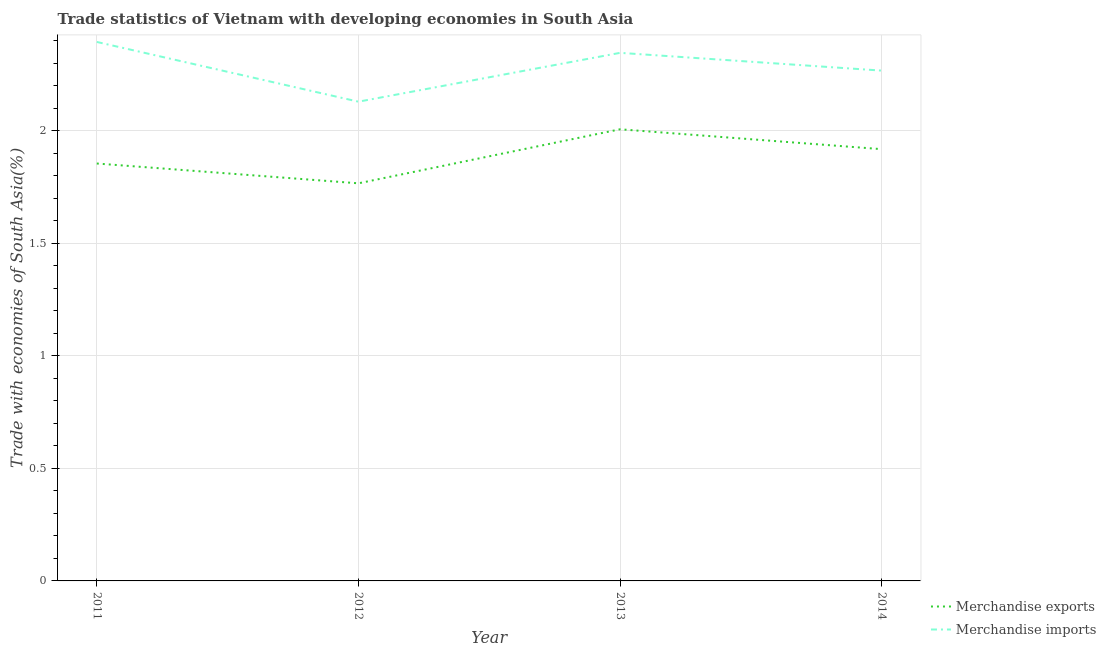How many different coloured lines are there?
Your answer should be compact. 2. What is the merchandise exports in 2014?
Keep it short and to the point. 1.92. Across all years, what is the maximum merchandise imports?
Keep it short and to the point. 2.39. Across all years, what is the minimum merchandise imports?
Ensure brevity in your answer.  2.13. What is the total merchandise imports in the graph?
Make the answer very short. 9.14. What is the difference between the merchandise imports in 2011 and that in 2013?
Provide a short and direct response. 0.05. What is the difference between the merchandise imports in 2012 and the merchandise exports in 2014?
Keep it short and to the point. 0.21. What is the average merchandise exports per year?
Ensure brevity in your answer.  1.89. In the year 2013, what is the difference between the merchandise imports and merchandise exports?
Your answer should be very brief. 0.34. What is the ratio of the merchandise exports in 2013 to that in 2014?
Your answer should be very brief. 1.05. Is the merchandise exports in 2011 less than that in 2012?
Offer a very short reply. No. What is the difference between the highest and the second highest merchandise imports?
Offer a very short reply. 0.05. What is the difference between the highest and the lowest merchandise imports?
Keep it short and to the point. 0.27. Is the merchandise exports strictly greater than the merchandise imports over the years?
Your answer should be compact. No. How many lines are there?
Give a very brief answer. 2. What is the difference between two consecutive major ticks on the Y-axis?
Provide a succinct answer. 0.5. Does the graph contain any zero values?
Make the answer very short. No. How many legend labels are there?
Provide a short and direct response. 2. How are the legend labels stacked?
Your answer should be compact. Vertical. What is the title of the graph?
Ensure brevity in your answer.  Trade statistics of Vietnam with developing economies in South Asia. What is the label or title of the X-axis?
Provide a succinct answer. Year. What is the label or title of the Y-axis?
Ensure brevity in your answer.  Trade with economies of South Asia(%). What is the Trade with economies of South Asia(%) in Merchandise exports in 2011?
Give a very brief answer. 1.85. What is the Trade with economies of South Asia(%) of Merchandise imports in 2011?
Your response must be concise. 2.39. What is the Trade with economies of South Asia(%) in Merchandise exports in 2012?
Provide a short and direct response. 1.77. What is the Trade with economies of South Asia(%) in Merchandise imports in 2012?
Keep it short and to the point. 2.13. What is the Trade with economies of South Asia(%) of Merchandise exports in 2013?
Offer a very short reply. 2.01. What is the Trade with economies of South Asia(%) of Merchandise imports in 2013?
Your response must be concise. 2.35. What is the Trade with economies of South Asia(%) of Merchandise exports in 2014?
Offer a very short reply. 1.92. What is the Trade with economies of South Asia(%) of Merchandise imports in 2014?
Give a very brief answer. 2.27. Across all years, what is the maximum Trade with economies of South Asia(%) of Merchandise exports?
Keep it short and to the point. 2.01. Across all years, what is the maximum Trade with economies of South Asia(%) in Merchandise imports?
Offer a terse response. 2.39. Across all years, what is the minimum Trade with economies of South Asia(%) of Merchandise exports?
Provide a succinct answer. 1.77. Across all years, what is the minimum Trade with economies of South Asia(%) in Merchandise imports?
Your response must be concise. 2.13. What is the total Trade with economies of South Asia(%) in Merchandise exports in the graph?
Your answer should be compact. 7.55. What is the total Trade with economies of South Asia(%) in Merchandise imports in the graph?
Your answer should be very brief. 9.14. What is the difference between the Trade with economies of South Asia(%) in Merchandise exports in 2011 and that in 2012?
Ensure brevity in your answer.  0.09. What is the difference between the Trade with economies of South Asia(%) in Merchandise imports in 2011 and that in 2012?
Offer a very short reply. 0.27. What is the difference between the Trade with economies of South Asia(%) of Merchandise exports in 2011 and that in 2013?
Keep it short and to the point. -0.15. What is the difference between the Trade with economies of South Asia(%) of Merchandise imports in 2011 and that in 2013?
Your answer should be compact. 0.05. What is the difference between the Trade with economies of South Asia(%) of Merchandise exports in 2011 and that in 2014?
Make the answer very short. -0.06. What is the difference between the Trade with economies of South Asia(%) in Merchandise imports in 2011 and that in 2014?
Your answer should be compact. 0.13. What is the difference between the Trade with economies of South Asia(%) in Merchandise exports in 2012 and that in 2013?
Provide a short and direct response. -0.24. What is the difference between the Trade with economies of South Asia(%) of Merchandise imports in 2012 and that in 2013?
Offer a very short reply. -0.22. What is the difference between the Trade with economies of South Asia(%) of Merchandise exports in 2012 and that in 2014?
Offer a very short reply. -0.15. What is the difference between the Trade with economies of South Asia(%) of Merchandise imports in 2012 and that in 2014?
Provide a succinct answer. -0.14. What is the difference between the Trade with economies of South Asia(%) of Merchandise exports in 2013 and that in 2014?
Keep it short and to the point. 0.09. What is the difference between the Trade with economies of South Asia(%) of Merchandise imports in 2013 and that in 2014?
Give a very brief answer. 0.08. What is the difference between the Trade with economies of South Asia(%) of Merchandise exports in 2011 and the Trade with economies of South Asia(%) of Merchandise imports in 2012?
Your answer should be compact. -0.27. What is the difference between the Trade with economies of South Asia(%) in Merchandise exports in 2011 and the Trade with economies of South Asia(%) in Merchandise imports in 2013?
Offer a terse response. -0.49. What is the difference between the Trade with economies of South Asia(%) in Merchandise exports in 2011 and the Trade with economies of South Asia(%) in Merchandise imports in 2014?
Ensure brevity in your answer.  -0.41. What is the difference between the Trade with economies of South Asia(%) in Merchandise exports in 2012 and the Trade with economies of South Asia(%) in Merchandise imports in 2013?
Give a very brief answer. -0.58. What is the difference between the Trade with economies of South Asia(%) in Merchandise exports in 2012 and the Trade with economies of South Asia(%) in Merchandise imports in 2014?
Provide a succinct answer. -0.5. What is the difference between the Trade with economies of South Asia(%) of Merchandise exports in 2013 and the Trade with economies of South Asia(%) of Merchandise imports in 2014?
Keep it short and to the point. -0.26. What is the average Trade with economies of South Asia(%) of Merchandise exports per year?
Your response must be concise. 1.89. What is the average Trade with economies of South Asia(%) of Merchandise imports per year?
Your answer should be very brief. 2.28. In the year 2011, what is the difference between the Trade with economies of South Asia(%) in Merchandise exports and Trade with economies of South Asia(%) in Merchandise imports?
Offer a terse response. -0.54. In the year 2012, what is the difference between the Trade with economies of South Asia(%) in Merchandise exports and Trade with economies of South Asia(%) in Merchandise imports?
Make the answer very short. -0.36. In the year 2013, what is the difference between the Trade with economies of South Asia(%) in Merchandise exports and Trade with economies of South Asia(%) in Merchandise imports?
Keep it short and to the point. -0.34. In the year 2014, what is the difference between the Trade with economies of South Asia(%) of Merchandise exports and Trade with economies of South Asia(%) of Merchandise imports?
Your answer should be very brief. -0.35. What is the ratio of the Trade with economies of South Asia(%) of Merchandise exports in 2011 to that in 2012?
Keep it short and to the point. 1.05. What is the ratio of the Trade with economies of South Asia(%) in Merchandise imports in 2011 to that in 2012?
Keep it short and to the point. 1.12. What is the ratio of the Trade with economies of South Asia(%) in Merchandise exports in 2011 to that in 2013?
Keep it short and to the point. 0.92. What is the ratio of the Trade with economies of South Asia(%) of Merchandise imports in 2011 to that in 2013?
Offer a very short reply. 1.02. What is the ratio of the Trade with economies of South Asia(%) of Merchandise exports in 2011 to that in 2014?
Offer a terse response. 0.97. What is the ratio of the Trade with economies of South Asia(%) in Merchandise imports in 2011 to that in 2014?
Give a very brief answer. 1.06. What is the ratio of the Trade with economies of South Asia(%) of Merchandise exports in 2012 to that in 2013?
Your response must be concise. 0.88. What is the ratio of the Trade with economies of South Asia(%) of Merchandise imports in 2012 to that in 2013?
Make the answer very short. 0.91. What is the ratio of the Trade with economies of South Asia(%) of Merchandise exports in 2012 to that in 2014?
Provide a short and direct response. 0.92. What is the ratio of the Trade with economies of South Asia(%) of Merchandise imports in 2012 to that in 2014?
Your response must be concise. 0.94. What is the ratio of the Trade with economies of South Asia(%) of Merchandise exports in 2013 to that in 2014?
Offer a very short reply. 1.05. What is the ratio of the Trade with economies of South Asia(%) in Merchandise imports in 2013 to that in 2014?
Your answer should be very brief. 1.03. What is the difference between the highest and the second highest Trade with economies of South Asia(%) in Merchandise exports?
Offer a terse response. 0.09. What is the difference between the highest and the second highest Trade with economies of South Asia(%) in Merchandise imports?
Give a very brief answer. 0.05. What is the difference between the highest and the lowest Trade with economies of South Asia(%) in Merchandise exports?
Keep it short and to the point. 0.24. What is the difference between the highest and the lowest Trade with economies of South Asia(%) of Merchandise imports?
Your response must be concise. 0.27. 